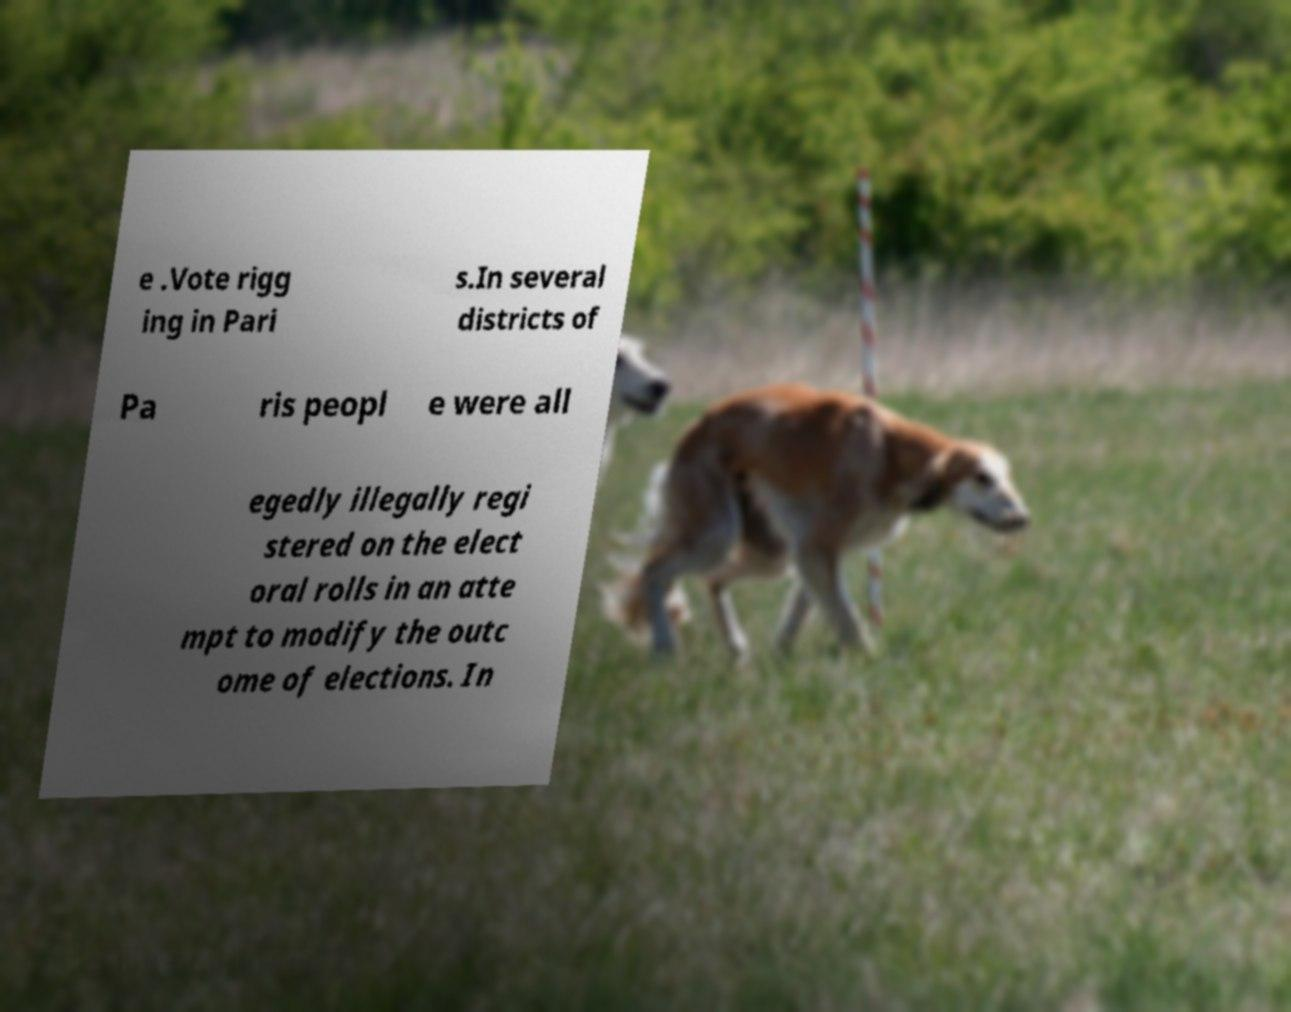Could you extract and type out the text from this image? e .Vote rigg ing in Pari s.In several districts of Pa ris peopl e were all egedly illegally regi stered on the elect oral rolls in an atte mpt to modify the outc ome of elections. In 